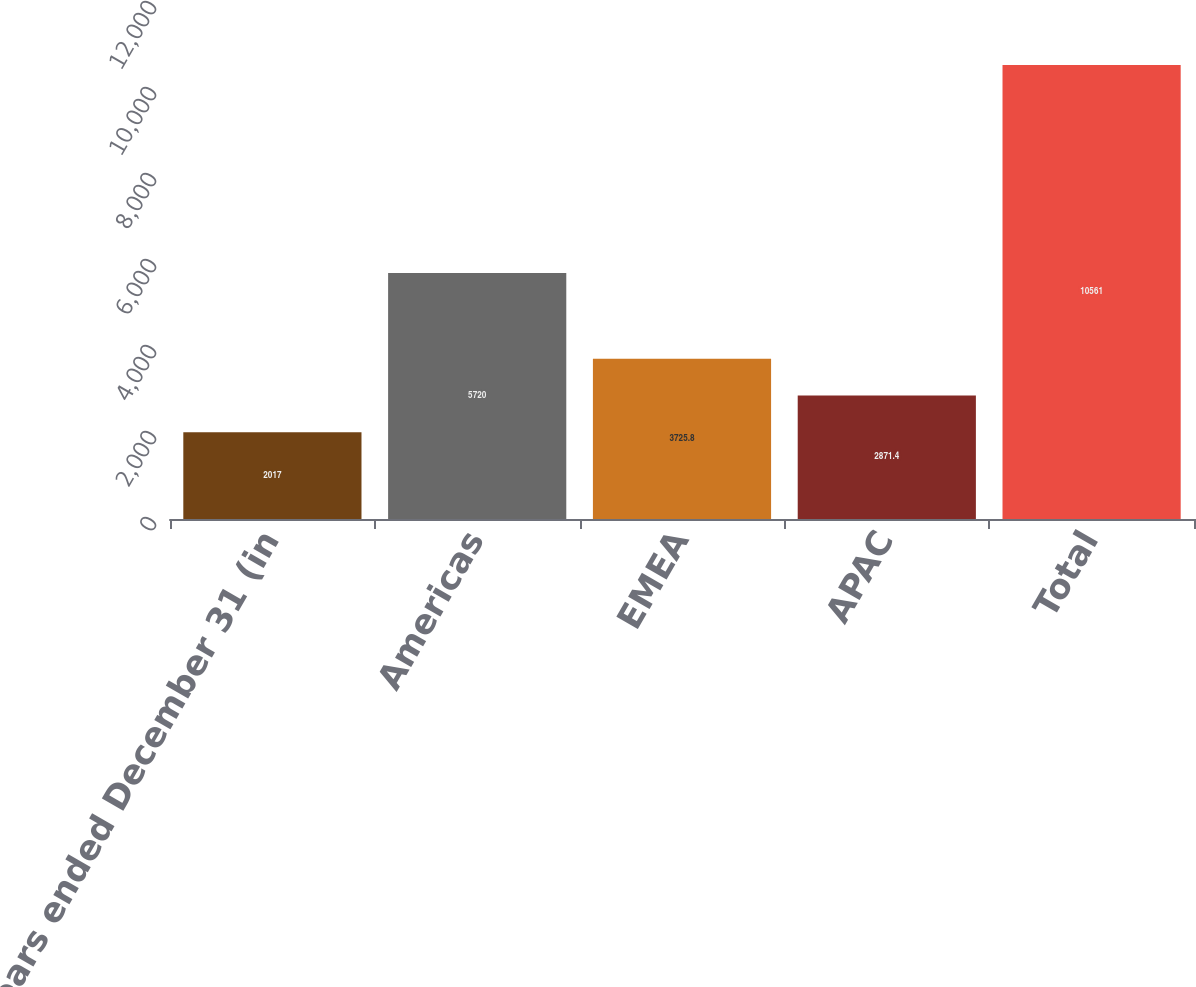Convert chart to OTSL. <chart><loc_0><loc_0><loc_500><loc_500><bar_chart><fcel>years ended December 31 (in<fcel>Americas<fcel>EMEA<fcel>APAC<fcel>Total<nl><fcel>2017<fcel>5720<fcel>3725.8<fcel>2871.4<fcel>10561<nl></chart> 